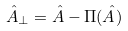<formula> <loc_0><loc_0><loc_500><loc_500>\hat { A } _ { \perp } = \hat { A } - \Pi ( \hat { A } )</formula> 